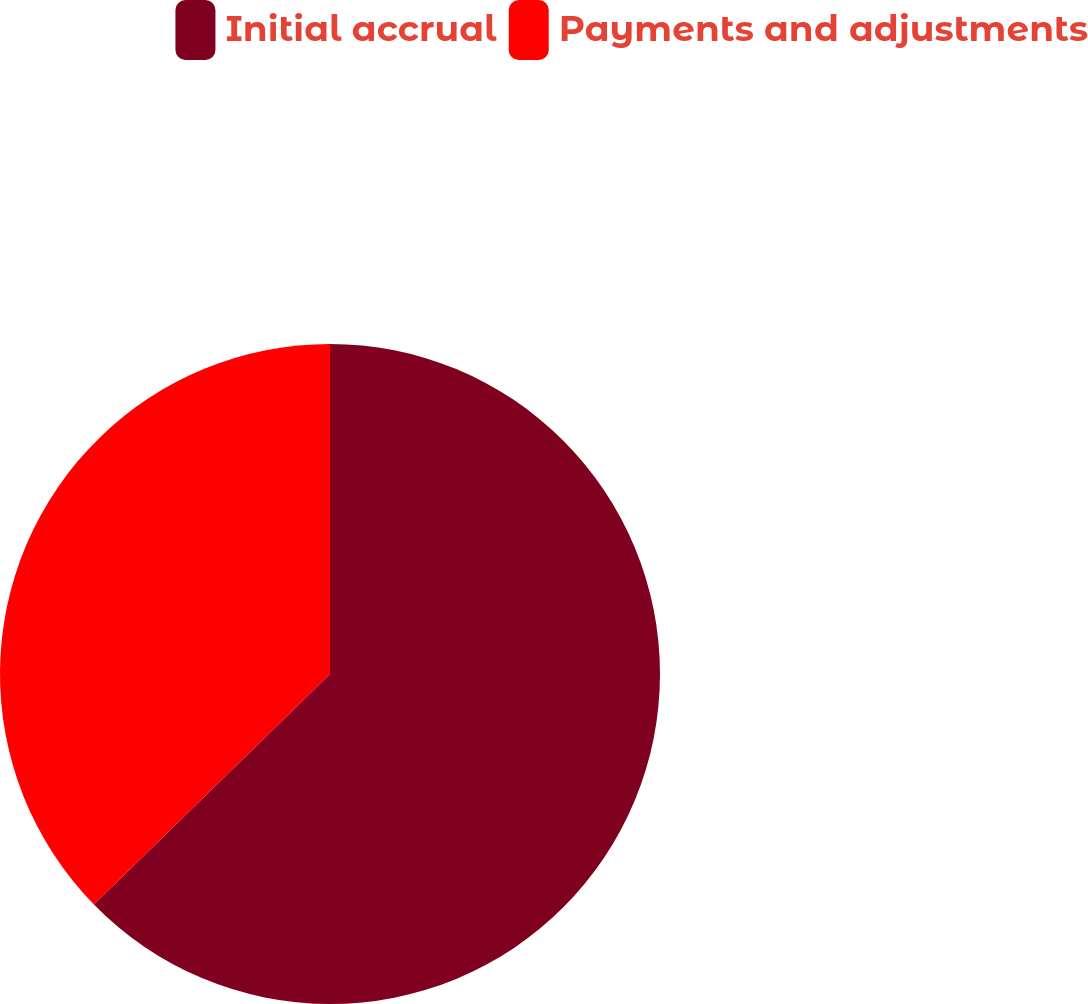Convert chart to OTSL. <chart><loc_0><loc_0><loc_500><loc_500><pie_chart><fcel>Initial accrual<fcel>Payments and adjustments<nl><fcel>62.69%<fcel>37.31%<nl></chart> 